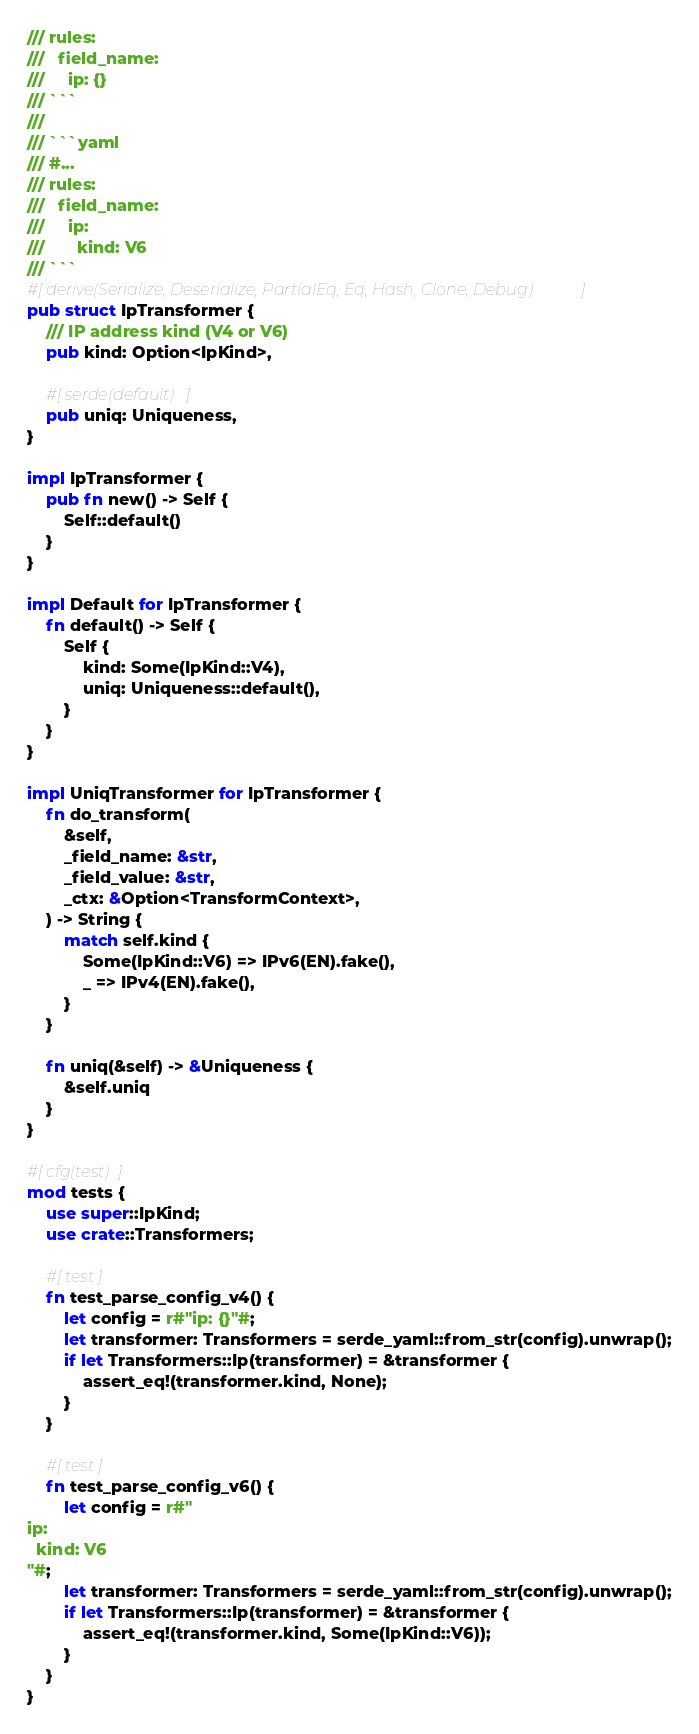Convert code to text. <code><loc_0><loc_0><loc_500><loc_500><_Rust_>/// rules:
///   field_name:
///     ip: {}
/// ```
///
/// ```yaml
/// #...
/// rules:
///   field_name:
///     ip:
///       kind: V6
/// ```
#[derive(Serialize, Deserialize, PartialEq, Eq, Hash, Clone, Debug)]
pub struct IpTransformer {
    /// IP address kind (V4 or V6)
    pub kind: Option<IpKind>,

    #[serde(default)]
    pub uniq: Uniqueness,
}

impl IpTransformer {
    pub fn new() -> Self {
        Self::default()
    }
}

impl Default for IpTransformer {
    fn default() -> Self {
        Self {
            kind: Some(IpKind::V4),
            uniq: Uniqueness::default(),
        }
    }
}

impl UniqTransformer for IpTransformer {
    fn do_transform(
        &self,
        _field_name: &str,
        _field_value: &str,
        _ctx: &Option<TransformContext>,
    ) -> String {
        match self.kind {
            Some(IpKind::V6) => IPv6(EN).fake(),
            _ => IPv4(EN).fake(),
        }
    }

    fn uniq(&self) -> &Uniqueness {
        &self.uniq
    }
}

#[cfg(test)]
mod tests {
    use super::IpKind;
    use crate::Transformers;

    #[test]
    fn test_parse_config_v4() {
        let config = r#"ip: {}"#;
        let transformer: Transformers = serde_yaml::from_str(config).unwrap();
        if let Transformers::Ip(transformer) = &transformer {
            assert_eq!(transformer.kind, None);
        }
    }

    #[test]
    fn test_parse_config_v6() {
        let config = r#"
ip:
  kind: V6
"#;
        let transformer: Transformers = serde_yaml::from_str(config).unwrap();
        if let Transformers::Ip(transformer) = &transformer {
            assert_eq!(transformer.kind, Some(IpKind::V6));
        }
    }
}
</code> 